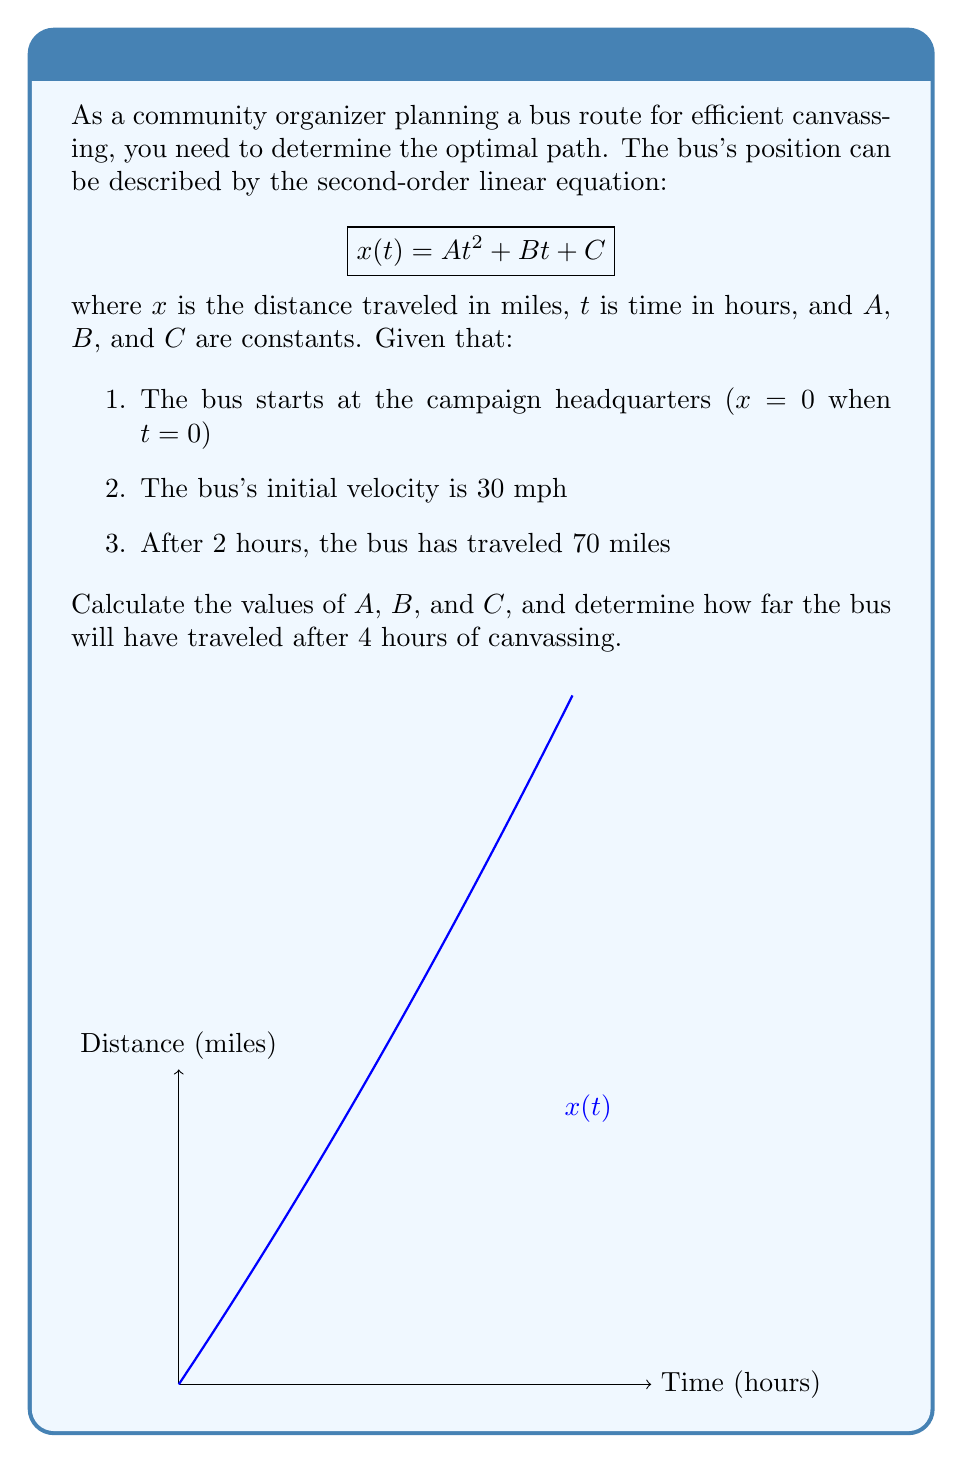What is the answer to this math problem? Let's solve this step-by-step:

1) We're given the equation $x(t) = At^2 + Bt + C$

2) Initial conditions:
   - At t = 0, x = 0, so $C = 0$
   - Initial velocity is 30 mph, so $\frac{dx}{dt}|_{t=0} = B = 30$

3) Our equation is now: $x(t) = At^2 + 30t$

4) After 2 hours, the bus has traveled 70 miles:
   $70 = A(2)^2 + 30(2)$
   $70 = 4A + 60$
   $10 = 4A$
   $A = 2.5$

5) Our final equation is: $x(t) = 2.5t^2 + 30t$

6) To find the distance after 4 hours, we substitute t = 4:
   $x(4) = 2.5(4)^2 + 30(4)$
   $x(4) = 2.5(16) + 120$
   $x(4) = 40 + 120 = 160$

Therefore, after 4 hours, the bus will have traveled 160 miles.
Answer: $A = 2.5$, $B = 30$, $C = 0$; Distance after 4 hours: 160 miles 